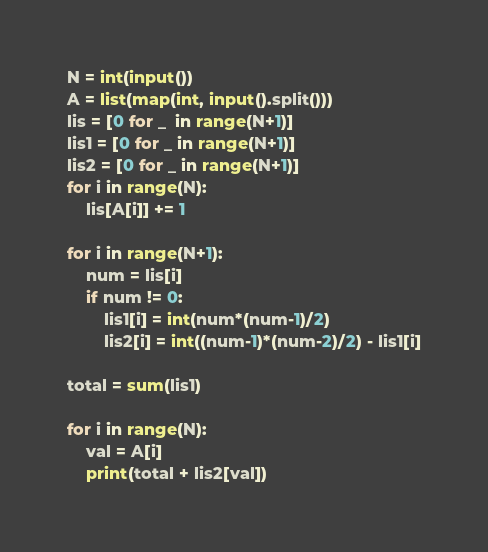Convert code to text. <code><loc_0><loc_0><loc_500><loc_500><_Python_>N = int(input())
A = list(map(int, input().split()))
lis = [0 for _  in range(N+1)]
lis1 = [0 for _ in range(N+1)]
lis2 = [0 for _ in range(N+1)]
for i in range(N):
    lis[A[i]] += 1

for i in range(N+1):
    num = lis[i]
    if num != 0:
        lis1[i] = int(num*(num-1)/2)
        lis2[i] = int((num-1)*(num-2)/2) - lis1[i]

total = sum(lis1)

for i in range(N):
    val = A[i]
    print(total + lis2[val])
</code> 